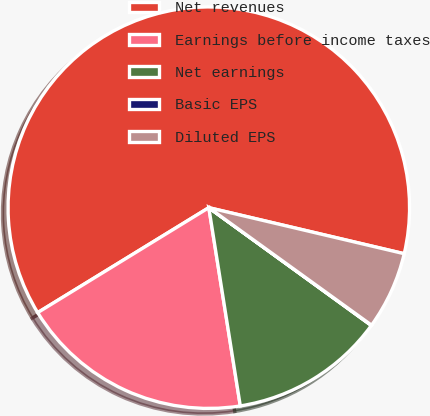<chart> <loc_0><loc_0><loc_500><loc_500><pie_chart><fcel>Net revenues<fcel>Earnings before income taxes<fcel>Net earnings<fcel>Basic EPS<fcel>Diluted EPS<nl><fcel>62.44%<fcel>18.75%<fcel>12.51%<fcel>0.03%<fcel>6.27%<nl></chart> 